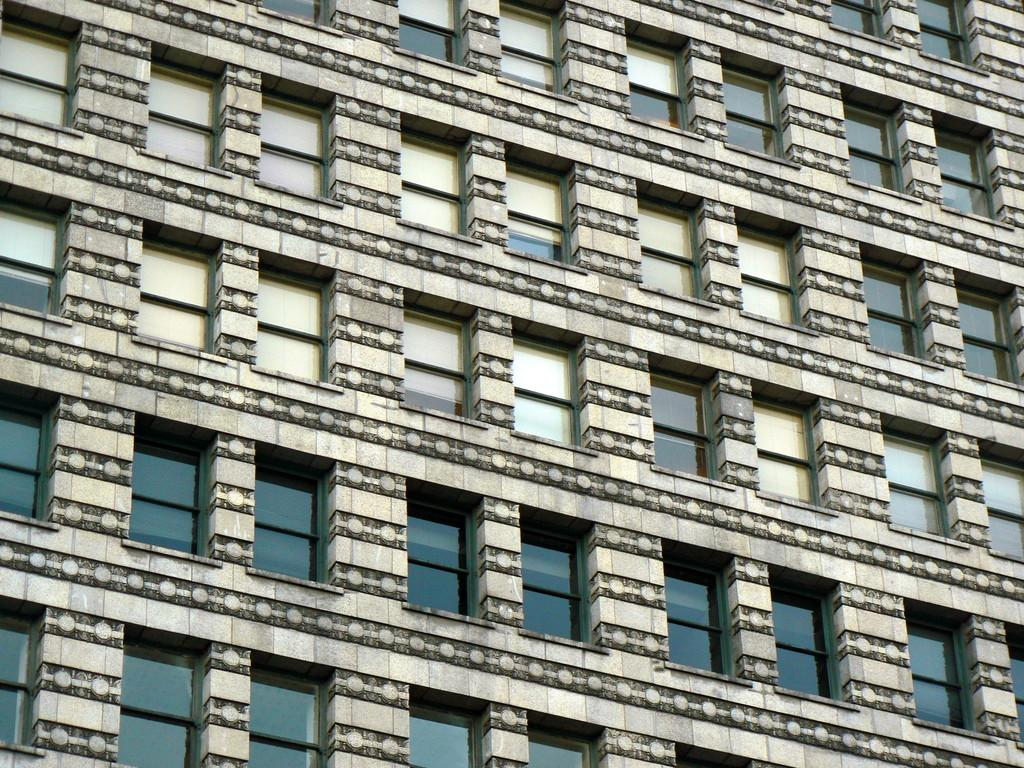What is the main structure visible in the image? There is a building in the image. What feature can be seen on the building? The building has windows. What type of pen is being used to write on the building's windows in the image? There is no pen or writing visible on the building's windows in the image. 